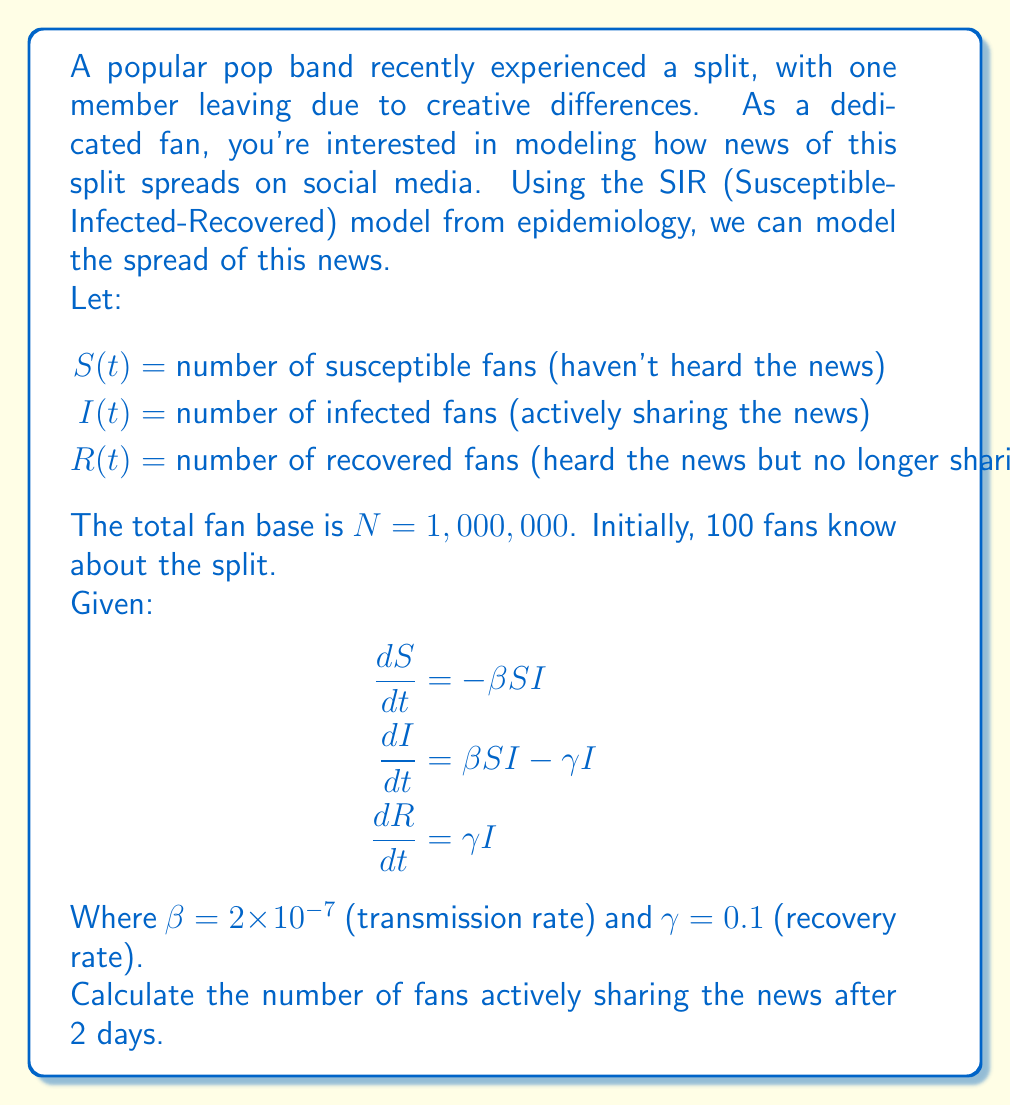Can you answer this question? To solve this problem, we need to use the SIR model equations and numerical integration. Let's break it down step-by-step:

1) Initial conditions:
   $S(0) = 999,900$
   $I(0) = 100$
   $R(0) = 0$

2) We need to solve the differential equation for $I(t)$. Since this is a non-linear system, we'll use Euler's method for numerical integration.

3) Euler's method: $y_{n+1} = y_n + h \cdot f(t_n, y_n)$
   Where $h$ is the step size. Let's use $h = 0.1$ days.

4) For $I(t)$, we have:
   $I_{n+1} = I_n + h \cdot (\beta S_n I_n - \gamma I_n)$

5) We also need to update $S(t)$ at each step:
   $S_{n+1} = S_n + h \cdot (-\beta S_n I_n)$

6) Let's calculate for 20 steps (2 days):

   Step 0: $S_0 = 999,900$, $I_0 = 100$
   Step 1: $I_1 = 100 + 0.1 \cdot (2 \times 10^{-7} \cdot 999,900 \cdot 100 - 0.1 \cdot 100) = 101.99$
           $S_1 = 999,900 - 0.1 \cdot (2 \times 10^{-7} \cdot 999,900 \cdot 100) = 999,898$
   Step 2: $I_2 = 101.99 + 0.1 \cdot (2 \times 10^{-7} \cdot 999,898 \cdot 101.99 - 0.1 \cdot 101.99) = 104.06$
           $S_2 = 999,898 - 0.1 \cdot (2 \times 10^{-7} \cdot 999,898 \cdot 101.99) = 999,896$

   ... (continue for 20 steps)

7) After 20 steps (2 days), we get:
   $I_{20} \approx 271.83$

8) Rounding to the nearest whole number, we get 272 fans actively sharing the news after 2 days.
Answer: 272 fans 